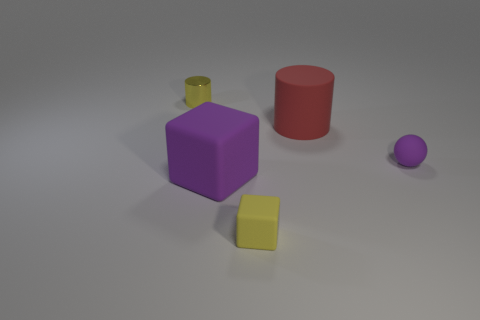Add 1 small blue matte cubes. How many objects exist? 6 Add 1 red objects. How many red objects are left? 2 Add 2 red objects. How many red objects exist? 3 Subtract all red cylinders. How many cylinders are left? 1 Subtract 0 blue blocks. How many objects are left? 5 Subtract all spheres. How many objects are left? 4 Subtract all yellow balls. Subtract all purple blocks. How many balls are left? 1 Subtract all blue spheres. How many purple cubes are left? 1 Subtract all big purple rubber things. Subtract all purple cubes. How many objects are left? 3 